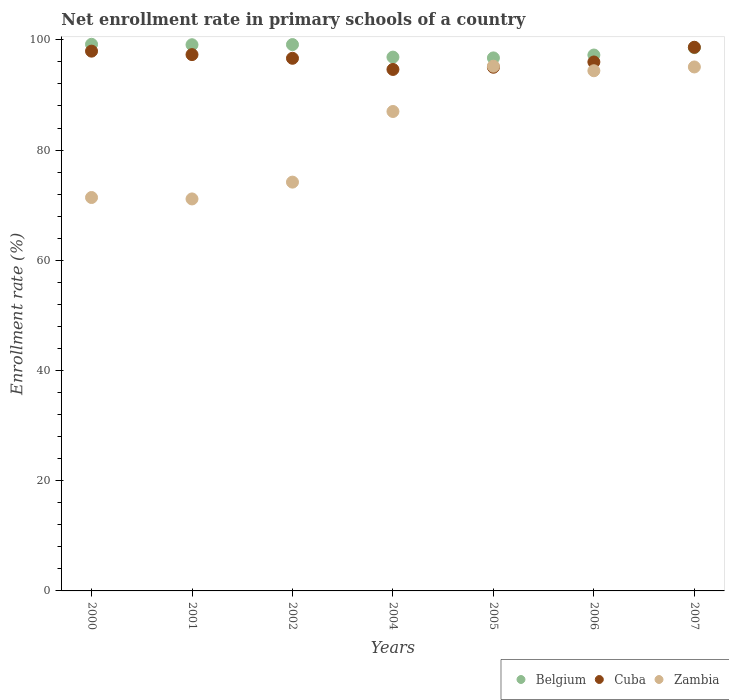What is the enrollment rate in primary schools in Cuba in 2007?
Make the answer very short. 98.65. Across all years, what is the maximum enrollment rate in primary schools in Cuba?
Provide a short and direct response. 98.65. Across all years, what is the minimum enrollment rate in primary schools in Cuba?
Give a very brief answer. 94.63. In which year was the enrollment rate in primary schools in Zambia maximum?
Provide a succinct answer. 2005. What is the total enrollment rate in primary schools in Belgium in the graph?
Ensure brevity in your answer.  686.87. What is the difference between the enrollment rate in primary schools in Cuba in 2000 and that in 2002?
Offer a terse response. 1.29. What is the difference between the enrollment rate in primary schools in Zambia in 2006 and the enrollment rate in primary schools in Cuba in 2002?
Keep it short and to the point. -2.26. What is the average enrollment rate in primary schools in Zambia per year?
Provide a short and direct response. 84.06. In the year 2005, what is the difference between the enrollment rate in primary schools in Cuba and enrollment rate in primary schools in Belgium?
Keep it short and to the point. -1.69. In how many years, is the enrollment rate in primary schools in Cuba greater than 88 %?
Your answer should be compact. 7. What is the ratio of the enrollment rate in primary schools in Cuba in 2000 to that in 2005?
Provide a succinct answer. 1.03. Is the enrollment rate in primary schools in Belgium in 2004 less than that in 2005?
Offer a very short reply. No. Is the difference between the enrollment rate in primary schools in Cuba in 2004 and 2006 greater than the difference between the enrollment rate in primary schools in Belgium in 2004 and 2006?
Give a very brief answer. No. What is the difference between the highest and the second highest enrollment rate in primary schools in Cuba?
Ensure brevity in your answer.  0.71. What is the difference between the highest and the lowest enrollment rate in primary schools in Belgium?
Ensure brevity in your answer.  2.47. In how many years, is the enrollment rate in primary schools in Belgium greater than the average enrollment rate in primary schools in Belgium taken over all years?
Offer a very short reply. 4. Is it the case that in every year, the sum of the enrollment rate in primary schools in Belgium and enrollment rate in primary schools in Zambia  is greater than the enrollment rate in primary schools in Cuba?
Your answer should be compact. Yes. Does the enrollment rate in primary schools in Zambia monotonically increase over the years?
Offer a very short reply. No. Is the enrollment rate in primary schools in Zambia strictly greater than the enrollment rate in primary schools in Cuba over the years?
Ensure brevity in your answer.  No. How many years are there in the graph?
Your answer should be very brief. 7. What is the difference between two consecutive major ticks on the Y-axis?
Your answer should be compact. 20. Are the values on the major ticks of Y-axis written in scientific E-notation?
Keep it short and to the point. No. Does the graph contain grids?
Offer a terse response. No. Where does the legend appear in the graph?
Ensure brevity in your answer.  Bottom right. How many legend labels are there?
Offer a terse response. 3. What is the title of the graph?
Give a very brief answer. Net enrollment rate in primary schools of a country. What is the label or title of the Y-axis?
Your response must be concise. Enrollment rate (%). What is the Enrollment rate (%) of Belgium in 2000?
Your response must be concise. 99.19. What is the Enrollment rate (%) of Cuba in 2000?
Give a very brief answer. 97.95. What is the Enrollment rate (%) of Zambia in 2000?
Make the answer very short. 71.39. What is the Enrollment rate (%) of Belgium in 2001?
Provide a short and direct response. 99.11. What is the Enrollment rate (%) in Cuba in 2001?
Your answer should be very brief. 97.32. What is the Enrollment rate (%) in Zambia in 2001?
Give a very brief answer. 71.13. What is the Enrollment rate (%) of Belgium in 2002?
Ensure brevity in your answer.  99.14. What is the Enrollment rate (%) in Cuba in 2002?
Offer a very short reply. 96.65. What is the Enrollment rate (%) of Zambia in 2002?
Ensure brevity in your answer.  74.18. What is the Enrollment rate (%) in Belgium in 2004?
Give a very brief answer. 96.87. What is the Enrollment rate (%) of Cuba in 2004?
Provide a succinct answer. 94.63. What is the Enrollment rate (%) of Zambia in 2004?
Make the answer very short. 87. What is the Enrollment rate (%) in Belgium in 2005?
Make the answer very short. 96.72. What is the Enrollment rate (%) of Cuba in 2005?
Your answer should be very brief. 95.03. What is the Enrollment rate (%) in Zambia in 2005?
Your answer should be very brief. 95.22. What is the Enrollment rate (%) of Belgium in 2006?
Offer a very short reply. 97.25. What is the Enrollment rate (%) of Cuba in 2006?
Keep it short and to the point. 95.98. What is the Enrollment rate (%) of Zambia in 2006?
Your answer should be compact. 94.39. What is the Enrollment rate (%) of Belgium in 2007?
Your response must be concise. 98.59. What is the Enrollment rate (%) of Cuba in 2007?
Provide a succinct answer. 98.65. What is the Enrollment rate (%) of Zambia in 2007?
Make the answer very short. 95.08. Across all years, what is the maximum Enrollment rate (%) in Belgium?
Offer a terse response. 99.19. Across all years, what is the maximum Enrollment rate (%) of Cuba?
Keep it short and to the point. 98.65. Across all years, what is the maximum Enrollment rate (%) of Zambia?
Your answer should be compact. 95.22. Across all years, what is the minimum Enrollment rate (%) in Belgium?
Make the answer very short. 96.72. Across all years, what is the minimum Enrollment rate (%) in Cuba?
Offer a very short reply. 94.63. Across all years, what is the minimum Enrollment rate (%) of Zambia?
Offer a terse response. 71.13. What is the total Enrollment rate (%) in Belgium in the graph?
Give a very brief answer. 686.87. What is the total Enrollment rate (%) in Cuba in the graph?
Keep it short and to the point. 676.22. What is the total Enrollment rate (%) of Zambia in the graph?
Provide a succinct answer. 588.39. What is the difference between the Enrollment rate (%) in Belgium in 2000 and that in 2001?
Keep it short and to the point. 0.08. What is the difference between the Enrollment rate (%) of Cuba in 2000 and that in 2001?
Make the answer very short. 0.63. What is the difference between the Enrollment rate (%) of Zambia in 2000 and that in 2001?
Give a very brief answer. 0.26. What is the difference between the Enrollment rate (%) of Belgium in 2000 and that in 2002?
Offer a terse response. 0.05. What is the difference between the Enrollment rate (%) in Cuba in 2000 and that in 2002?
Your answer should be compact. 1.29. What is the difference between the Enrollment rate (%) in Zambia in 2000 and that in 2002?
Your response must be concise. -2.79. What is the difference between the Enrollment rate (%) in Belgium in 2000 and that in 2004?
Your answer should be compact. 2.33. What is the difference between the Enrollment rate (%) in Cuba in 2000 and that in 2004?
Your answer should be very brief. 3.32. What is the difference between the Enrollment rate (%) in Zambia in 2000 and that in 2004?
Provide a short and direct response. -15.61. What is the difference between the Enrollment rate (%) of Belgium in 2000 and that in 2005?
Offer a very short reply. 2.47. What is the difference between the Enrollment rate (%) of Cuba in 2000 and that in 2005?
Ensure brevity in your answer.  2.92. What is the difference between the Enrollment rate (%) of Zambia in 2000 and that in 2005?
Offer a terse response. -23.83. What is the difference between the Enrollment rate (%) of Belgium in 2000 and that in 2006?
Keep it short and to the point. 1.94. What is the difference between the Enrollment rate (%) in Cuba in 2000 and that in 2006?
Your answer should be compact. 1.97. What is the difference between the Enrollment rate (%) of Zambia in 2000 and that in 2006?
Keep it short and to the point. -23. What is the difference between the Enrollment rate (%) in Belgium in 2000 and that in 2007?
Your response must be concise. 0.6. What is the difference between the Enrollment rate (%) of Cuba in 2000 and that in 2007?
Ensure brevity in your answer.  -0.71. What is the difference between the Enrollment rate (%) in Zambia in 2000 and that in 2007?
Your answer should be very brief. -23.69. What is the difference between the Enrollment rate (%) in Belgium in 2001 and that in 2002?
Provide a short and direct response. -0.03. What is the difference between the Enrollment rate (%) in Cuba in 2001 and that in 2002?
Your answer should be compact. 0.67. What is the difference between the Enrollment rate (%) in Zambia in 2001 and that in 2002?
Give a very brief answer. -3.05. What is the difference between the Enrollment rate (%) of Belgium in 2001 and that in 2004?
Provide a succinct answer. 2.25. What is the difference between the Enrollment rate (%) of Cuba in 2001 and that in 2004?
Offer a very short reply. 2.69. What is the difference between the Enrollment rate (%) of Zambia in 2001 and that in 2004?
Give a very brief answer. -15.87. What is the difference between the Enrollment rate (%) in Belgium in 2001 and that in 2005?
Your answer should be very brief. 2.39. What is the difference between the Enrollment rate (%) of Cuba in 2001 and that in 2005?
Offer a terse response. 2.29. What is the difference between the Enrollment rate (%) of Zambia in 2001 and that in 2005?
Your answer should be compact. -24.09. What is the difference between the Enrollment rate (%) of Belgium in 2001 and that in 2006?
Make the answer very short. 1.86. What is the difference between the Enrollment rate (%) in Cuba in 2001 and that in 2006?
Your response must be concise. 1.34. What is the difference between the Enrollment rate (%) in Zambia in 2001 and that in 2006?
Provide a succinct answer. -23.26. What is the difference between the Enrollment rate (%) in Belgium in 2001 and that in 2007?
Keep it short and to the point. 0.52. What is the difference between the Enrollment rate (%) of Cuba in 2001 and that in 2007?
Your answer should be compact. -1.33. What is the difference between the Enrollment rate (%) in Zambia in 2001 and that in 2007?
Provide a short and direct response. -23.95. What is the difference between the Enrollment rate (%) of Belgium in 2002 and that in 2004?
Provide a short and direct response. 2.27. What is the difference between the Enrollment rate (%) of Cuba in 2002 and that in 2004?
Ensure brevity in your answer.  2.02. What is the difference between the Enrollment rate (%) of Zambia in 2002 and that in 2004?
Give a very brief answer. -12.82. What is the difference between the Enrollment rate (%) of Belgium in 2002 and that in 2005?
Your answer should be compact. 2.42. What is the difference between the Enrollment rate (%) of Cuba in 2002 and that in 2005?
Make the answer very short. 1.63. What is the difference between the Enrollment rate (%) in Zambia in 2002 and that in 2005?
Make the answer very short. -21.04. What is the difference between the Enrollment rate (%) in Belgium in 2002 and that in 2006?
Make the answer very short. 1.89. What is the difference between the Enrollment rate (%) in Cuba in 2002 and that in 2006?
Make the answer very short. 0.67. What is the difference between the Enrollment rate (%) in Zambia in 2002 and that in 2006?
Ensure brevity in your answer.  -20.21. What is the difference between the Enrollment rate (%) in Belgium in 2002 and that in 2007?
Your answer should be very brief. 0.55. What is the difference between the Enrollment rate (%) in Cuba in 2002 and that in 2007?
Offer a terse response. -2. What is the difference between the Enrollment rate (%) in Zambia in 2002 and that in 2007?
Ensure brevity in your answer.  -20.9. What is the difference between the Enrollment rate (%) of Belgium in 2004 and that in 2005?
Provide a short and direct response. 0.14. What is the difference between the Enrollment rate (%) of Cuba in 2004 and that in 2005?
Offer a terse response. -0.4. What is the difference between the Enrollment rate (%) in Zambia in 2004 and that in 2005?
Ensure brevity in your answer.  -8.22. What is the difference between the Enrollment rate (%) in Belgium in 2004 and that in 2006?
Your answer should be compact. -0.38. What is the difference between the Enrollment rate (%) in Cuba in 2004 and that in 2006?
Ensure brevity in your answer.  -1.35. What is the difference between the Enrollment rate (%) in Zambia in 2004 and that in 2006?
Offer a very short reply. -7.39. What is the difference between the Enrollment rate (%) in Belgium in 2004 and that in 2007?
Your response must be concise. -1.72. What is the difference between the Enrollment rate (%) of Cuba in 2004 and that in 2007?
Make the answer very short. -4.02. What is the difference between the Enrollment rate (%) of Zambia in 2004 and that in 2007?
Make the answer very short. -8.08. What is the difference between the Enrollment rate (%) in Belgium in 2005 and that in 2006?
Your answer should be compact. -0.53. What is the difference between the Enrollment rate (%) in Cuba in 2005 and that in 2006?
Ensure brevity in your answer.  -0.96. What is the difference between the Enrollment rate (%) of Zambia in 2005 and that in 2006?
Your answer should be compact. 0.82. What is the difference between the Enrollment rate (%) of Belgium in 2005 and that in 2007?
Provide a short and direct response. -1.87. What is the difference between the Enrollment rate (%) of Cuba in 2005 and that in 2007?
Provide a succinct answer. -3.63. What is the difference between the Enrollment rate (%) of Zambia in 2005 and that in 2007?
Your response must be concise. 0.14. What is the difference between the Enrollment rate (%) of Belgium in 2006 and that in 2007?
Provide a short and direct response. -1.34. What is the difference between the Enrollment rate (%) in Cuba in 2006 and that in 2007?
Give a very brief answer. -2.67. What is the difference between the Enrollment rate (%) of Zambia in 2006 and that in 2007?
Provide a succinct answer. -0.68. What is the difference between the Enrollment rate (%) of Belgium in 2000 and the Enrollment rate (%) of Cuba in 2001?
Offer a terse response. 1.87. What is the difference between the Enrollment rate (%) of Belgium in 2000 and the Enrollment rate (%) of Zambia in 2001?
Your answer should be very brief. 28.06. What is the difference between the Enrollment rate (%) in Cuba in 2000 and the Enrollment rate (%) in Zambia in 2001?
Your response must be concise. 26.82. What is the difference between the Enrollment rate (%) of Belgium in 2000 and the Enrollment rate (%) of Cuba in 2002?
Provide a succinct answer. 2.54. What is the difference between the Enrollment rate (%) in Belgium in 2000 and the Enrollment rate (%) in Zambia in 2002?
Your answer should be compact. 25.01. What is the difference between the Enrollment rate (%) in Cuba in 2000 and the Enrollment rate (%) in Zambia in 2002?
Your answer should be compact. 23.77. What is the difference between the Enrollment rate (%) of Belgium in 2000 and the Enrollment rate (%) of Cuba in 2004?
Your answer should be very brief. 4.56. What is the difference between the Enrollment rate (%) of Belgium in 2000 and the Enrollment rate (%) of Zambia in 2004?
Your answer should be compact. 12.19. What is the difference between the Enrollment rate (%) of Cuba in 2000 and the Enrollment rate (%) of Zambia in 2004?
Offer a very short reply. 10.95. What is the difference between the Enrollment rate (%) in Belgium in 2000 and the Enrollment rate (%) in Cuba in 2005?
Provide a short and direct response. 4.16. What is the difference between the Enrollment rate (%) of Belgium in 2000 and the Enrollment rate (%) of Zambia in 2005?
Offer a very short reply. 3.97. What is the difference between the Enrollment rate (%) in Cuba in 2000 and the Enrollment rate (%) in Zambia in 2005?
Provide a succinct answer. 2.73. What is the difference between the Enrollment rate (%) of Belgium in 2000 and the Enrollment rate (%) of Cuba in 2006?
Ensure brevity in your answer.  3.21. What is the difference between the Enrollment rate (%) of Belgium in 2000 and the Enrollment rate (%) of Zambia in 2006?
Provide a short and direct response. 4.8. What is the difference between the Enrollment rate (%) in Cuba in 2000 and the Enrollment rate (%) in Zambia in 2006?
Ensure brevity in your answer.  3.55. What is the difference between the Enrollment rate (%) of Belgium in 2000 and the Enrollment rate (%) of Cuba in 2007?
Ensure brevity in your answer.  0.54. What is the difference between the Enrollment rate (%) of Belgium in 2000 and the Enrollment rate (%) of Zambia in 2007?
Keep it short and to the point. 4.11. What is the difference between the Enrollment rate (%) in Cuba in 2000 and the Enrollment rate (%) in Zambia in 2007?
Provide a succinct answer. 2.87. What is the difference between the Enrollment rate (%) of Belgium in 2001 and the Enrollment rate (%) of Cuba in 2002?
Offer a very short reply. 2.46. What is the difference between the Enrollment rate (%) in Belgium in 2001 and the Enrollment rate (%) in Zambia in 2002?
Keep it short and to the point. 24.93. What is the difference between the Enrollment rate (%) in Cuba in 2001 and the Enrollment rate (%) in Zambia in 2002?
Offer a terse response. 23.14. What is the difference between the Enrollment rate (%) of Belgium in 2001 and the Enrollment rate (%) of Cuba in 2004?
Offer a very short reply. 4.48. What is the difference between the Enrollment rate (%) of Belgium in 2001 and the Enrollment rate (%) of Zambia in 2004?
Make the answer very short. 12.11. What is the difference between the Enrollment rate (%) of Cuba in 2001 and the Enrollment rate (%) of Zambia in 2004?
Provide a succinct answer. 10.32. What is the difference between the Enrollment rate (%) of Belgium in 2001 and the Enrollment rate (%) of Cuba in 2005?
Your response must be concise. 4.08. What is the difference between the Enrollment rate (%) of Belgium in 2001 and the Enrollment rate (%) of Zambia in 2005?
Your answer should be compact. 3.89. What is the difference between the Enrollment rate (%) of Cuba in 2001 and the Enrollment rate (%) of Zambia in 2005?
Give a very brief answer. 2.1. What is the difference between the Enrollment rate (%) in Belgium in 2001 and the Enrollment rate (%) in Cuba in 2006?
Ensure brevity in your answer.  3.13. What is the difference between the Enrollment rate (%) in Belgium in 2001 and the Enrollment rate (%) in Zambia in 2006?
Your response must be concise. 4.72. What is the difference between the Enrollment rate (%) of Cuba in 2001 and the Enrollment rate (%) of Zambia in 2006?
Provide a succinct answer. 2.93. What is the difference between the Enrollment rate (%) of Belgium in 2001 and the Enrollment rate (%) of Cuba in 2007?
Your answer should be very brief. 0.46. What is the difference between the Enrollment rate (%) in Belgium in 2001 and the Enrollment rate (%) in Zambia in 2007?
Your answer should be very brief. 4.03. What is the difference between the Enrollment rate (%) in Cuba in 2001 and the Enrollment rate (%) in Zambia in 2007?
Give a very brief answer. 2.24. What is the difference between the Enrollment rate (%) in Belgium in 2002 and the Enrollment rate (%) in Cuba in 2004?
Your answer should be very brief. 4.51. What is the difference between the Enrollment rate (%) in Belgium in 2002 and the Enrollment rate (%) in Zambia in 2004?
Make the answer very short. 12.14. What is the difference between the Enrollment rate (%) in Cuba in 2002 and the Enrollment rate (%) in Zambia in 2004?
Provide a succinct answer. 9.65. What is the difference between the Enrollment rate (%) in Belgium in 2002 and the Enrollment rate (%) in Cuba in 2005?
Give a very brief answer. 4.11. What is the difference between the Enrollment rate (%) of Belgium in 2002 and the Enrollment rate (%) of Zambia in 2005?
Offer a terse response. 3.92. What is the difference between the Enrollment rate (%) of Cuba in 2002 and the Enrollment rate (%) of Zambia in 2005?
Make the answer very short. 1.43. What is the difference between the Enrollment rate (%) of Belgium in 2002 and the Enrollment rate (%) of Cuba in 2006?
Provide a short and direct response. 3.16. What is the difference between the Enrollment rate (%) of Belgium in 2002 and the Enrollment rate (%) of Zambia in 2006?
Ensure brevity in your answer.  4.75. What is the difference between the Enrollment rate (%) in Cuba in 2002 and the Enrollment rate (%) in Zambia in 2006?
Your answer should be compact. 2.26. What is the difference between the Enrollment rate (%) in Belgium in 2002 and the Enrollment rate (%) in Cuba in 2007?
Make the answer very short. 0.49. What is the difference between the Enrollment rate (%) of Belgium in 2002 and the Enrollment rate (%) of Zambia in 2007?
Offer a very short reply. 4.06. What is the difference between the Enrollment rate (%) of Cuba in 2002 and the Enrollment rate (%) of Zambia in 2007?
Keep it short and to the point. 1.57. What is the difference between the Enrollment rate (%) in Belgium in 2004 and the Enrollment rate (%) in Cuba in 2005?
Ensure brevity in your answer.  1.84. What is the difference between the Enrollment rate (%) in Belgium in 2004 and the Enrollment rate (%) in Zambia in 2005?
Give a very brief answer. 1.65. What is the difference between the Enrollment rate (%) of Cuba in 2004 and the Enrollment rate (%) of Zambia in 2005?
Give a very brief answer. -0.59. What is the difference between the Enrollment rate (%) in Belgium in 2004 and the Enrollment rate (%) in Cuba in 2006?
Provide a short and direct response. 0.88. What is the difference between the Enrollment rate (%) of Belgium in 2004 and the Enrollment rate (%) of Zambia in 2006?
Provide a succinct answer. 2.47. What is the difference between the Enrollment rate (%) in Cuba in 2004 and the Enrollment rate (%) in Zambia in 2006?
Make the answer very short. 0.23. What is the difference between the Enrollment rate (%) in Belgium in 2004 and the Enrollment rate (%) in Cuba in 2007?
Offer a very short reply. -1.79. What is the difference between the Enrollment rate (%) of Belgium in 2004 and the Enrollment rate (%) of Zambia in 2007?
Give a very brief answer. 1.79. What is the difference between the Enrollment rate (%) in Cuba in 2004 and the Enrollment rate (%) in Zambia in 2007?
Offer a very short reply. -0.45. What is the difference between the Enrollment rate (%) of Belgium in 2005 and the Enrollment rate (%) of Cuba in 2006?
Ensure brevity in your answer.  0.74. What is the difference between the Enrollment rate (%) in Belgium in 2005 and the Enrollment rate (%) in Zambia in 2006?
Offer a terse response. 2.33. What is the difference between the Enrollment rate (%) of Cuba in 2005 and the Enrollment rate (%) of Zambia in 2006?
Your answer should be very brief. 0.63. What is the difference between the Enrollment rate (%) in Belgium in 2005 and the Enrollment rate (%) in Cuba in 2007?
Your answer should be very brief. -1.93. What is the difference between the Enrollment rate (%) of Belgium in 2005 and the Enrollment rate (%) of Zambia in 2007?
Your answer should be compact. 1.64. What is the difference between the Enrollment rate (%) of Cuba in 2005 and the Enrollment rate (%) of Zambia in 2007?
Give a very brief answer. -0.05. What is the difference between the Enrollment rate (%) in Belgium in 2006 and the Enrollment rate (%) in Cuba in 2007?
Your answer should be very brief. -1.41. What is the difference between the Enrollment rate (%) in Belgium in 2006 and the Enrollment rate (%) in Zambia in 2007?
Keep it short and to the point. 2.17. What is the difference between the Enrollment rate (%) in Cuba in 2006 and the Enrollment rate (%) in Zambia in 2007?
Offer a very short reply. 0.9. What is the average Enrollment rate (%) of Belgium per year?
Offer a very short reply. 98.12. What is the average Enrollment rate (%) in Cuba per year?
Your response must be concise. 96.6. What is the average Enrollment rate (%) of Zambia per year?
Ensure brevity in your answer.  84.06. In the year 2000, what is the difference between the Enrollment rate (%) in Belgium and Enrollment rate (%) in Cuba?
Provide a succinct answer. 1.24. In the year 2000, what is the difference between the Enrollment rate (%) of Belgium and Enrollment rate (%) of Zambia?
Your answer should be very brief. 27.8. In the year 2000, what is the difference between the Enrollment rate (%) of Cuba and Enrollment rate (%) of Zambia?
Offer a very short reply. 26.56. In the year 2001, what is the difference between the Enrollment rate (%) in Belgium and Enrollment rate (%) in Cuba?
Your answer should be compact. 1.79. In the year 2001, what is the difference between the Enrollment rate (%) of Belgium and Enrollment rate (%) of Zambia?
Your answer should be compact. 27.98. In the year 2001, what is the difference between the Enrollment rate (%) in Cuba and Enrollment rate (%) in Zambia?
Offer a terse response. 26.19. In the year 2002, what is the difference between the Enrollment rate (%) of Belgium and Enrollment rate (%) of Cuba?
Offer a very short reply. 2.49. In the year 2002, what is the difference between the Enrollment rate (%) in Belgium and Enrollment rate (%) in Zambia?
Offer a terse response. 24.96. In the year 2002, what is the difference between the Enrollment rate (%) in Cuba and Enrollment rate (%) in Zambia?
Your answer should be compact. 22.47. In the year 2004, what is the difference between the Enrollment rate (%) in Belgium and Enrollment rate (%) in Cuba?
Keep it short and to the point. 2.24. In the year 2004, what is the difference between the Enrollment rate (%) in Belgium and Enrollment rate (%) in Zambia?
Your response must be concise. 9.87. In the year 2004, what is the difference between the Enrollment rate (%) of Cuba and Enrollment rate (%) of Zambia?
Your answer should be compact. 7.63. In the year 2005, what is the difference between the Enrollment rate (%) of Belgium and Enrollment rate (%) of Cuba?
Keep it short and to the point. 1.69. In the year 2005, what is the difference between the Enrollment rate (%) in Belgium and Enrollment rate (%) in Zambia?
Keep it short and to the point. 1.5. In the year 2005, what is the difference between the Enrollment rate (%) in Cuba and Enrollment rate (%) in Zambia?
Give a very brief answer. -0.19. In the year 2006, what is the difference between the Enrollment rate (%) in Belgium and Enrollment rate (%) in Cuba?
Your response must be concise. 1.26. In the year 2006, what is the difference between the Enrollment rate (%) in Belgium and Enrollment rate (%) in Zambia?
Give a very brief answer. 2.85. In the year 2006, what is the difference between the Enrollment rate (%) in Cuba and Enrollment rate (%) in Zambia?
Your answer should be very brief. 1.59. In the year 2007, what is the difference between the Enrollment rate (%) in Belgium and Enrollment rate (%) in Cuba?
Make the answer very short. -0.06. In the year 2007, what is the difference between the Enrollment rate (%) in Belgium and Enrollment rate (%) in Zambia?
Offer a very short reply. 3.51. In the year 2007, what is the difference between the Enrollment rate (%) in Cuba and Enrollment rate (%) in Zambia?
Your response must be concise. 3.57. What is the ratio of the Enrollment rate (%) of Cuba in 2000 to that in 2001?
Ensure brevity in your answer.  1.01. What is the ratio of the Enrollment rate (%) of Zambia in 2000 to that in 2001?
Offer a terse response. 1. What is the ratio of the Enrollment rate (%) of Belgium in 2000 to that in 2002?
Give a very brief answer. 1. What is the ratio of the Enrollment rate (%) in Cuba in 2000 to that in 2002?
Give a very brief answer. 1.01. What is the ratio of the Enrollment rate (%) of Zambia in 2000 to that in 2002?
Make the answer very short. 0.96. What is the ratio of the Enrollment rate (%) in Belgium in 2000 to that in 2004?
Your response must be concise. 1.02. What is the ratio of the Enrollment rate (%) in Cuba in 2000 to that in 2004?
Your answer should be compact. 1.04. What is the ratio of the Enrollment rate (%) in Zambia in 2000 to that in 2004?
Your answer should be compact. 0.82. What is the ratio of the Enrollment rate (%) of Belgium in 2000 to that in 2005?
Give a very brief answer. 1.03. What is the ratio of the Enrollment rate (%) in Cuba in 2000 to that in 2005?
Provide a short and direct response. 1.03. What is the ratio of the Enrollment rate (%) of Zambia in 2000 to that in 2005?
Provide a short and direct response. 0.75. What is the ratio of the Enrollment rate (%) of Belgium in 2000 to that in 2006?
Offer a very short reply. 1.02. What is the ratio of the Enrollment rate (%) in Cuba in 2000 to that in 2006?
Your answer should be very brief. 1.02. What is the ratio of the Enrollment rate (%) of Zambia in 2000 to that in 2006?
Give a very brief answer. 0.76. What is the ratio of the Enrollment rate (%) of Belgium in 2000 to that in 2007?
Provide a succinct answer. 1.01. What is the ratio of the Enrollment rate (%) of Cuba in 2000 to that in 2007?
Give a very brief answer. 0.99. What is the ratio of the Enrollment rate (%) in Zambia in 2000 to that in 2007?
Give a very brief answer. 0.75. What is the ratio of the Enrollment rate (%) of Cuba in 2001 to that in 2002?
Provide a succinct answer. 1.01. What is the ratio of the Enrollment rate (%) of Zambia in 2001 to that in 2002?
Give a very brief answer. 0.96. What is the ratio of the Enrollment rate (%) of Belgium in 2001 to that in 2004?
Give a very brief answer. 1.02. What is the ratio of the Enrollment rate (%) in Cuba in 2001 to that in 2004?
Your answer should be very brief. 1.03. What is the ratio of the Enrollment rate (%) in Zambia in 2001 to that in 2004?
Offer a very short reply. 0.82. What is the ratio of the Enrollment rate (%) of Belgium in 2001 to that in 2005?
Your answer should be very brief. 1.02. What is the ratio of the Enrollment rate (%) in Cuba in 2001 to that in 2005?
Make the answer very short. 1.02. What is the ratio of the Enrollment rate (%) of Zambia in 2001 to that in 2005?
Give a very brief answer. 0.75. What is the ratio of the Enrollment rate (%) of Belgium in 2001 to that in 2006?
Ensure brevity in your answer.  1.02. What is the ratio of the Enrollment rate (%) in Cuba in 2001 to that in 2006?
Keep it short and to the point. 1.01. What is the ratio of the Enrollment rate (%) in Zambia in 2001 to that in 2006?
Offer a terse response. 0.75. What is the ratio of the Enrollment rate (%) in Belgium in 2001 to that in 2007?
Provide a succinct answer. 1.01. What is the ratio of the Enrollment rate (%) in Cuba in 2001 to that in 2007?
Ensure brevity in your answer.  0.99. What is the ratio of the Enrollment rate (%) of Zambia in 2001 to that in 2007?
Your answer should be very brief. 0.75. What is the ratio of the Enrollment rate (%) in Belgium in 2002 to that in 2004?
Your answer should be compact. 1.02. What is the ratio of the Enrollment rate (%) in Cuba in 2002 to that in 2004?
Your answer should be compact. 1.02. What is the ratio of the Enrollment rate (%) in Zambia in 2002 to that in 2004?
Your answer should be very brief. 0.85. What is the ratio of the Enrollment rate (%) in Belgium in 2002 to that in 2005?
Make the answer very short. 1.02. What is the ratio of the Enrollment rate (%) of Cuba in 2002 to that in 2005?
Provide a succinct answer. 1.02. What is the ratio of the Enrollment rate (%) of Zambia in 2002 to that in 2005?
Offer a terse response. 0.78. What is the ratio of the Enrollment rate (%) in Belgium in 2002 to that in 2006?
Give a very brief answer. 1.02. What is the ratio of the Enrollment rate (%) of Cuba in 2002 to that in 2006?
Provide a succinct answer. 1.01. What is the ratio of the Enrollment rate (%) in Zambia in 2002 to that in 2006?
Keep it short and to the point. 0.79. What is the ratio of the Enrollment rate (%) in Belgium in 2002 to that in 2007?
Ensure brevity in your answer.  1.01. What is the ratio of the Enrollment rate (%) in Cuba in 2002 to that in 2007?
Provide a short and direct response. 0.98. What is the ratio of the Enrollment rate (%) in Zambia in 2002 to that in 2007?
Your response must be concise. 0.78. What is the ratio of the Enrollment rate (%) of Belgium in 2004 to that in 2005?
Your answer should be very brief. 1. What is the ratio of the Enrollment rate (%) of Zambia in 2004 to that in 2005?
Provide a short and direct response. 0.91. What is the ratio of the Enrollment rate (%) of Belgium in 2004 to that in 2006?
Your answer should be very brief. 1. What is the ratio of the Enrollment rate (%) in Cuba in 2004 to that in 2006?
Provide a succinct answer. 0.99. What is the ratio of the Enrollment rate (%) of Zambia in 2004 to that in 2006?
Offer a terse response. 0.92. What is the ratio of the Enrollment rate (%) of Belgium in 2004 to that in 2007?
Provide a short and direct response. 0.98. What is the ratio of the Enrollment rate (%) in Cuba in 2004 to that in 2007?
Offer a very short reply. 0.96. What is the ratio of the Enrollment rate (%) in Zambia in 2004 to that in 2007?
Keep it short and to the point. 0.92. What is the ratio of the Enrollment rate (%) of Zambia in 2005 to that in 2006?
Ensure brevity in your answer.  1.01. What is the ratio of the Enrollment rate (%) of Belgium in 2005 to that in 2007?
Provide a succinct answer. 0.98. What is the ratio of the Enrollment rate (%) of Cuba in 2005 to that in 2007?
Offer a very short reply. 0.96. What is the ratio of the Enrollment rate (%) in Belgium in 2006 to that in 2007?
Your answer should be compact. 0.99. What is the ratio of the Enrollment rate (%) in Cuba in 2006 to that in 2007?
Ensure brevity in your answer.  0.97. What is the ratio of the Enrollment rate (%) of Zambia in 2006 to that in 2007?
Ensure brevity in your answer.  0.99. What is the difference between the highest and the second highest Enrollment rate (%) of Belgium?
Make the answer very short. 0.05. What is the difference between the highest and the second highest Enrollment rate (%) of Cuba?
Offer a very short reply. 0.71. What is the difference between the highest and the second highest Enrollment rate (%) in Zambia?
Ensure brevity in your answer.  0.14. What is the difference between the highest and the lowest Enrollment rate (%) in Belgium?
Make the answer very short. 2.47. What is the difference between the highest and the lowest Enrollment rate (%) of Cuba?
Keep it short and to the point. 4.02. What is the difference between the highest and the lowest Enrollment rate (%) of Zambia?
Offer a very short reply. 24.09. 